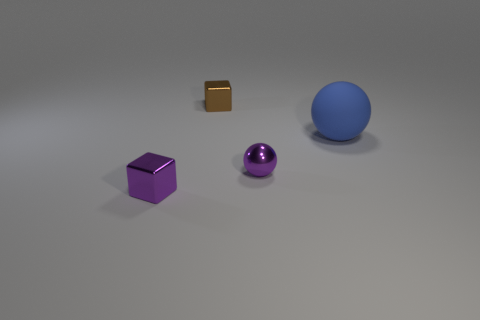How many other things are there of the same color as the rubber thing?
Ensure brevity in your answer.  0. What number of tiny spheres are on the left side of the tiny metallic thing on the left side of the small cube that is behind the big ball?
Provide a succinct answer. 0. Do the purple shiny object on the right side of the purple cube and the tiny brown shiny cube have the same size?
Offer a terse response. Yes. Is the number of brown metallic things that are in front of the purple metal ball less than the number of purple balls in front of the big sphere?
Ensure brevity in your answer.  Yes. Is the number of tiny purple spheres that are to the right of the tiny purple block less than the number of shiny spheres?
Offer a terse response. No. Does the tiny purple ball have the same material as the brown thing?
Give a very brief answer. Yes. What number of purple objects are the same material as the brown thing?
Your answer should be very brief. 2. What is the color of the sphere that is the same material as the brown cube?
Provide a succinct answer. Purple. What is the shape of the tiny brown thing?
Offer a very short reply. Cube. What is the cube that is in front of the tiny purple ball made of?
Make the answer very short. Metal. 